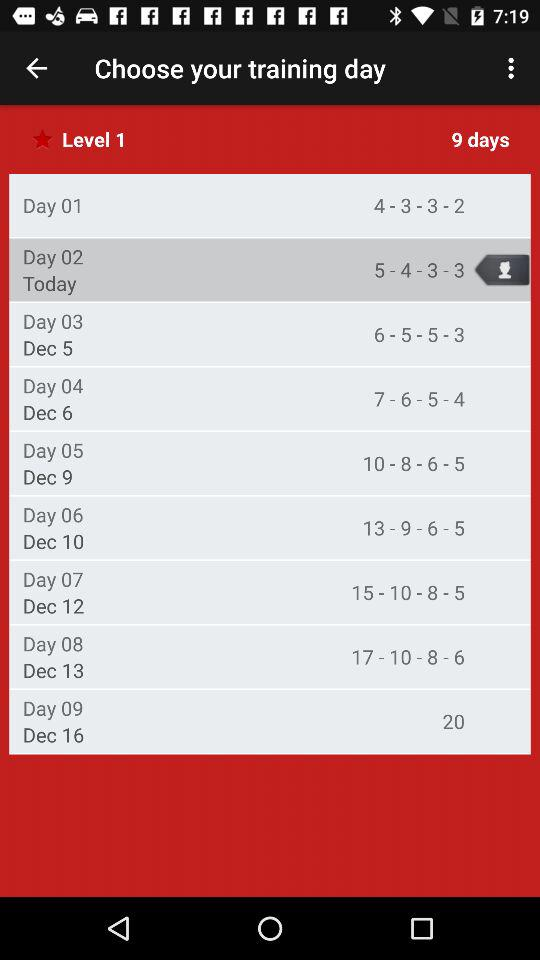How many days are there of level 1 training? There are 9 days of level 1 training. 